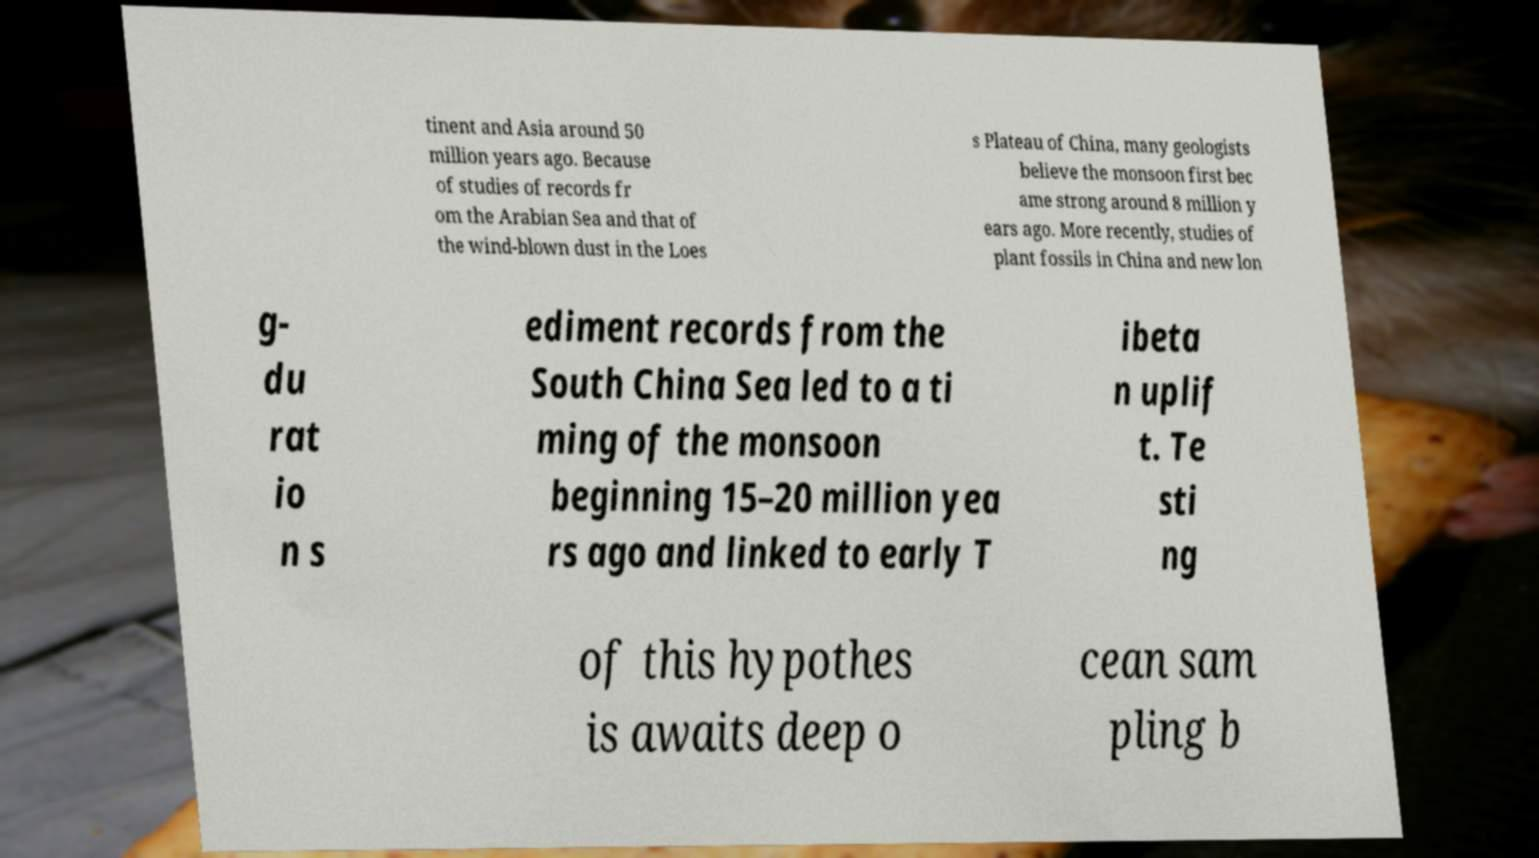Can you accurately transcribe the text from the provided image for me? tinent and Asia around 50 million years ago. Because of studies of records fr om the Arabian Sea and that of the wind-blown dust in the Loes s Plateau of China, many geologists believe the monsoon first bec ame strong around 8 million y ears ago. More recently, studies of plant fossils in China and new lon g- du rat io n s ediment records from the South China Sea led to a ti ming of the monsoon beginning 15–20 million yea rs ago and linked to early T ibeta n uplif t. Te sti ng of this hypothes is awaits deep o cean sam pling b 